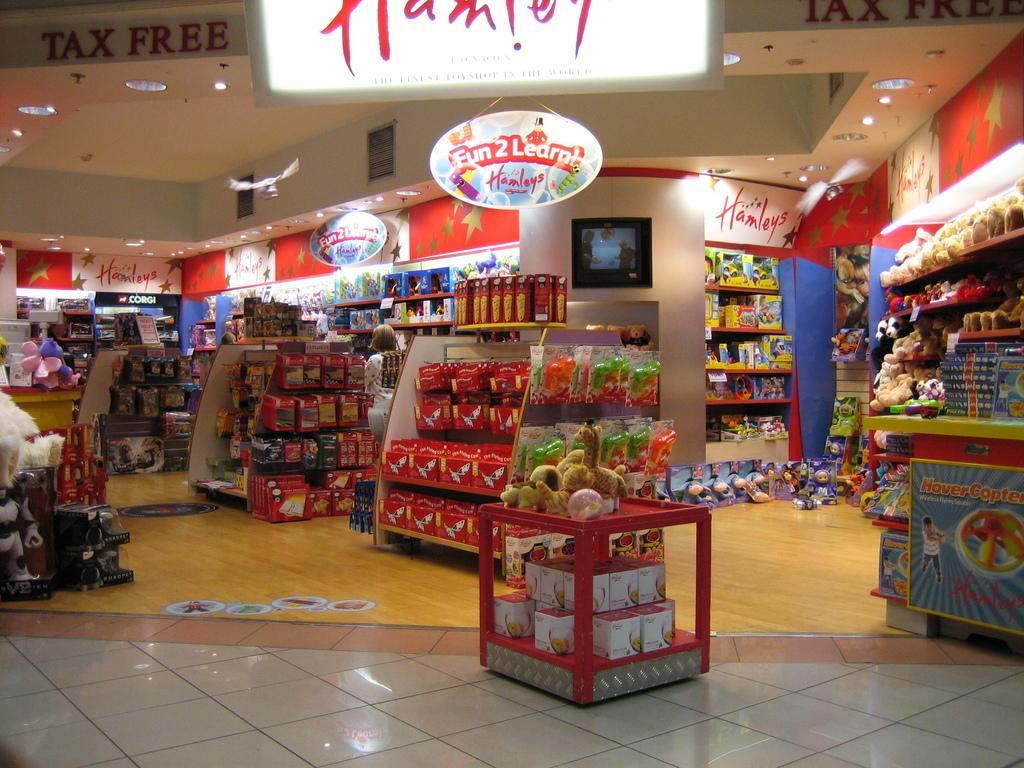<image>
Create a compact narrative representing the image presented. a sign that says fun 2 learn in a shop 